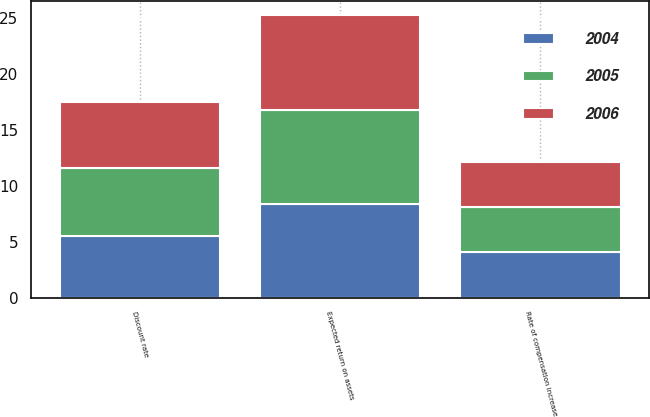Convert chart to OTSL. <chart><loc_0><loc_0><loc_500><loc_500><stacked_bar_chart><ecel><fcel>Discount rate<fcel>Expected return on assets<fcel>Rate of compensation increase<nl><fcel>2004<fcel>5.5<fcel>8.4<fcel>4.1<nl><fcel>2006<fcel>5.9<fcel>8.4<fcel>4<nl><fcel>2005<fcel>6.1<fcel>8.4<fcel>4<nl></chart> 